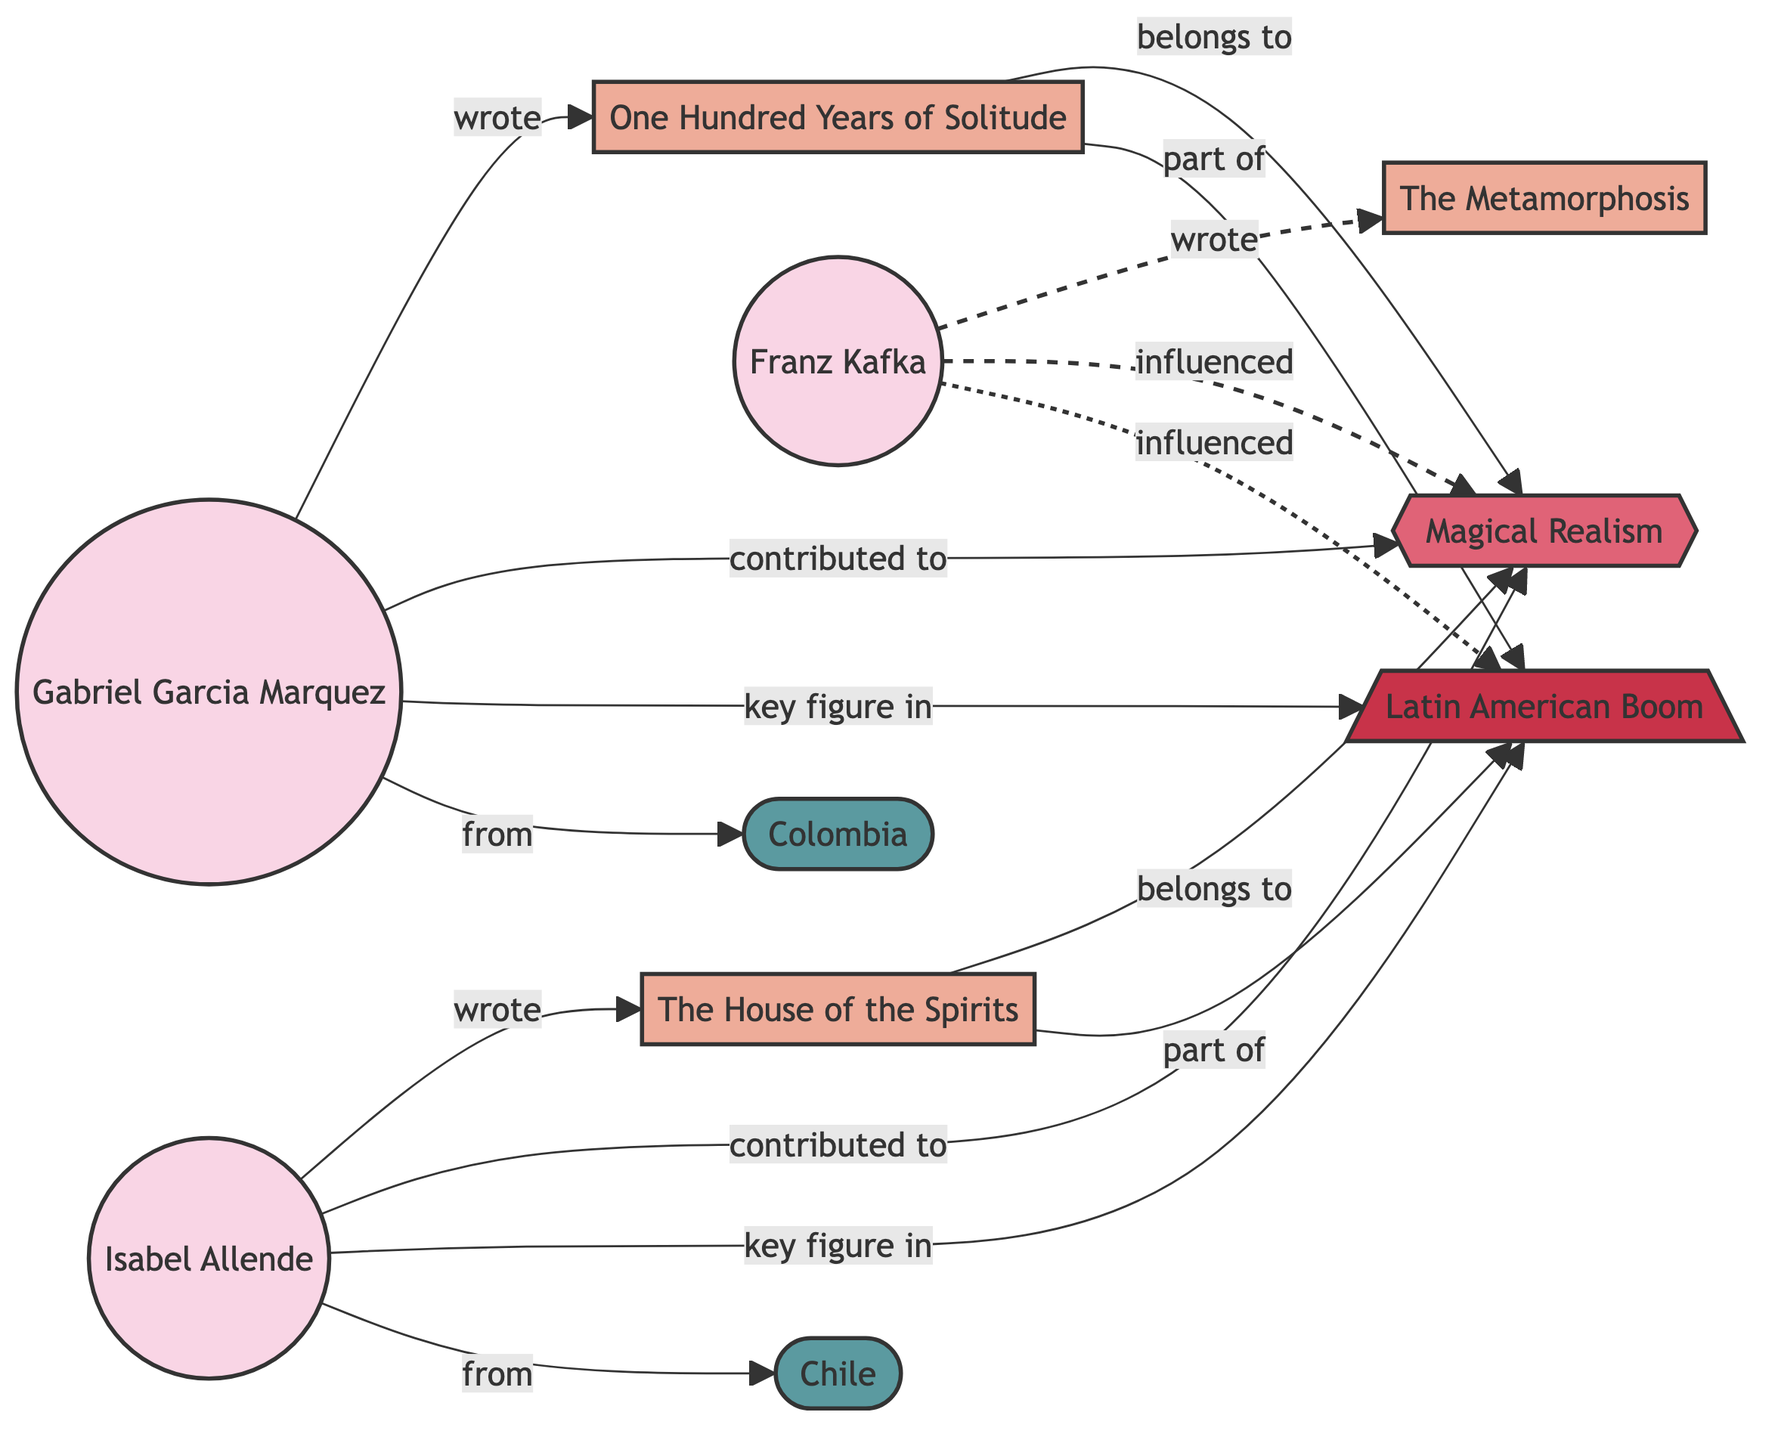What is the title of the book written by Gabriel Garcia Marquez? The diagram shows an edge labeled "wrote" connecting Gabriel Garcia Marquez to "One Hundred Years of Solitude," indicating that he is the author of this book.
Answer: One Hundred Years of Solitude Which genre does "The House of the Spirits" belong to? The diagram includes an edge labeled "belongs to" connecting the book "The House of the Spirits" to "Magical Realism," demonstrating that this book is categorized under this genre.
Answer: Magical Realism How many authors are there in the diagram? By examining the nodes in the diagram, we see three authors: Gabriel Garcia Marquez, Franz Kafka, and Isabel Allende. Therefore, the total number of authors is three.
Answer: 3 Who is a key figure in the Latin American Boom? The diagram shows edges labeled "key figure in" connecting both Gabriel Garcia Marquez and Isabel Allende to "Latin American Boom." Thus, both authors are recognized as significant contributors to this literary movement.
Answer: Gabriel Garcia Marquez, Isabel Allende Which country is associated with Isabel Allende? The diagram indicates that Isabel Allende is connected to "Chile" through the edge labeled "from." This explicitly states her nationality.
Answer: Chile How does Franz Kafka influence Magical Realism? The diagram exhibits a dashed edge labeled "influenced," connecting Franz Kafka to "Magical Realism." This signifies that Kafka had a significant impact on this genre, rather than being a contributor or key figure.
Answer: influenced What type of relationship exists between "One Hundred Years of Solitude" and "Latin American Boom"? The diagram displays an edge labeled "part of" which connects the book "One Hundred Years of Solitude" to the "Latin American Boom," indicating that this book is a component of that literary movement.
Answer: part of Which author is from Colombia? The diagram indicates an edge labeled "from" connecting Gabriel Garcia Marquez to "Colombia," confirming that he is identified with this country.
Answer: Gabriel Garcia Marquez What is the relationship between Franz Kafka and the book "Metamorphosis"? The diagram clearly shows a direct edge labeled "wrote" from Franz Kafka to "The Metamorphosis," thus establishing that he is the author of this particular work.
Answer: wrote 